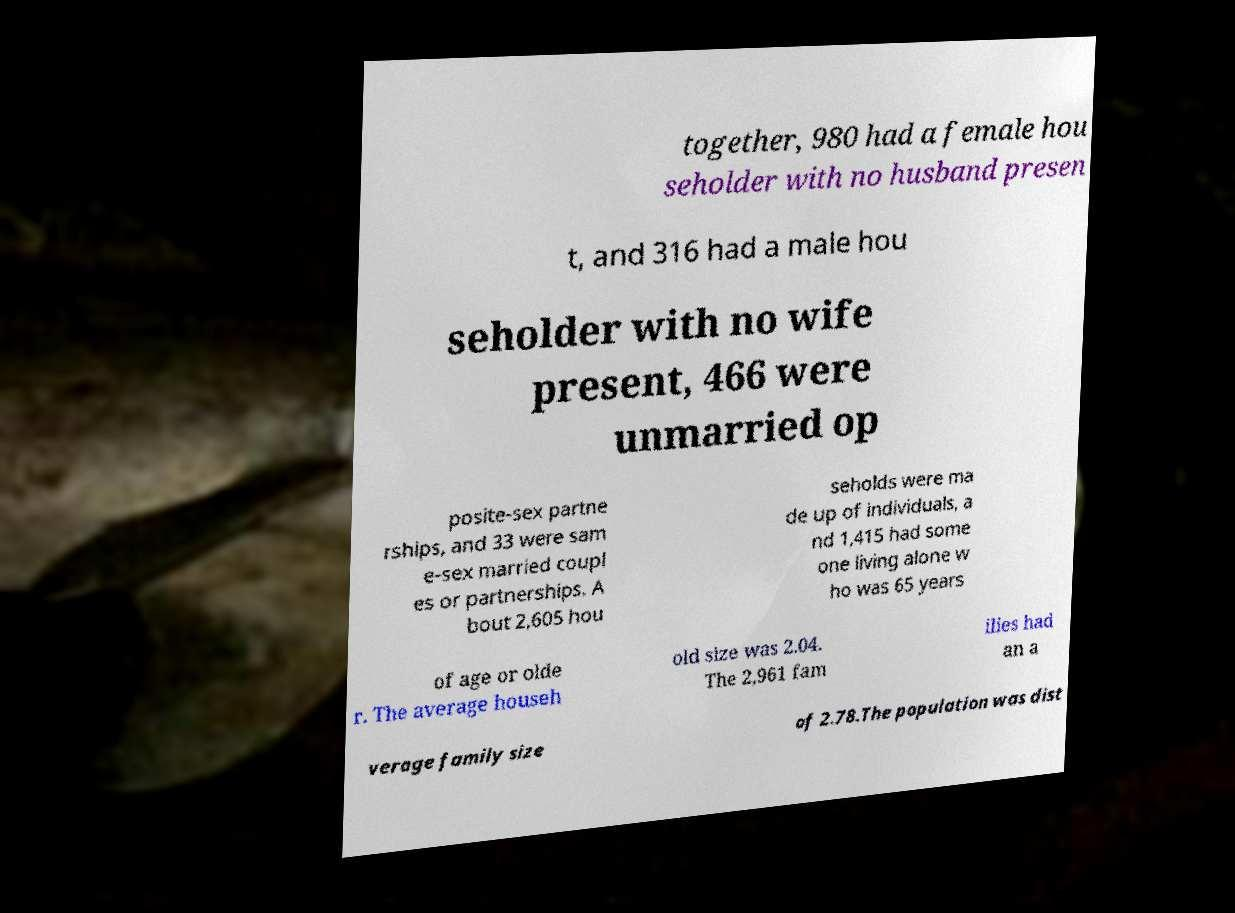What messages or text are displayed in this image? I need them in a readable, typed format. together, 980 had a female hou seholder with no husband presen t, and 316 had a male hou seholder with no wife present, 466 were unmarried op posite-sex partne rships, and 33 were sam e-sex married coupl es or partnerships. A bout 2,605 hou seholds were ma de up of individuals, a nd 1,415 had some one living alone w ho was 65 years of age or olde r. The average househ old size was 2.04. The 2,961 fam ilies had an a verage family size of 2.78.The population was dist 